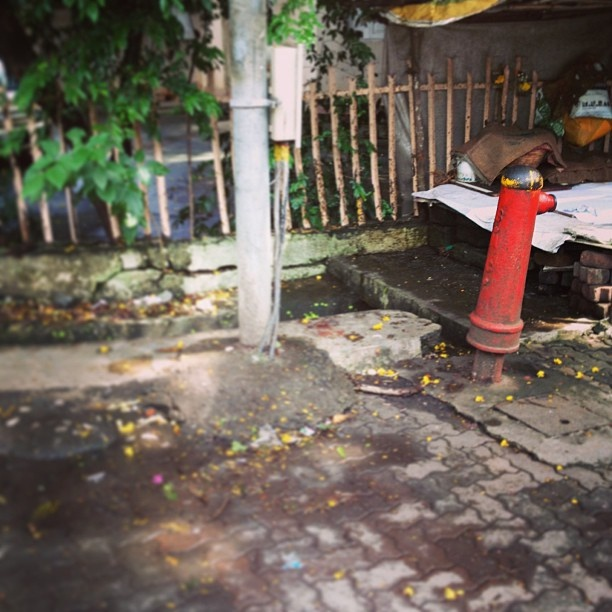Describe the objects in this image and their specific colors. I can see a fire hydrant in black, red, brown, and gray tones in this image. 